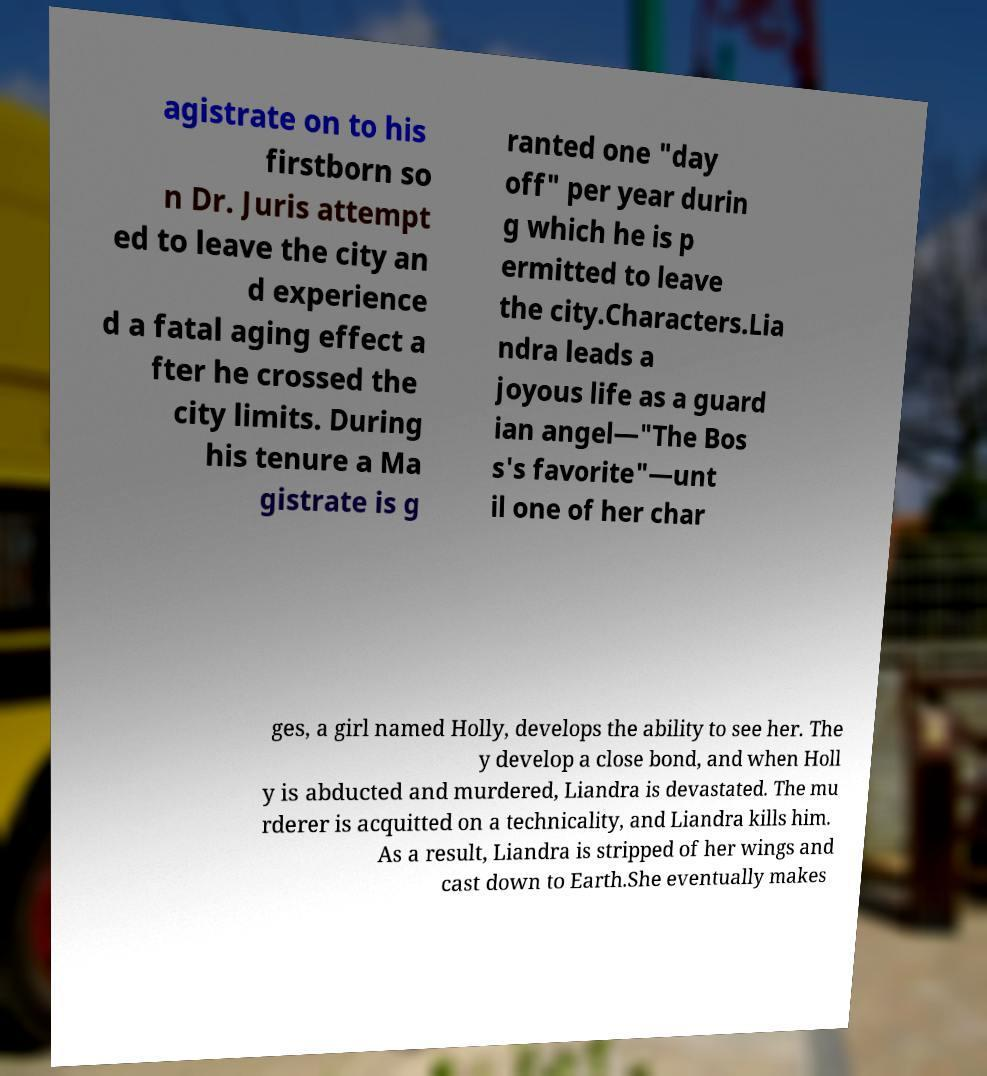Please read and relay the text visible in this image. What does it say? agistrate on to his firstborn so n Dr. Juris attempt ed to leave the city an d experience d a fatal aging effect a fter he crossed the city limits. During his tenure a Ma gistrate is g ranted one "day off" per year durin g which he is p ermitted to leave the city.Characters.Lia ndra leads a joyous life as a guard ian angel—"The Bos s's favorite"—unt il one of her char ges, a girl named Holly, develops the ability to see her. The y develop a close bond, and when Holl y is abducted and murdered, Liandra is devastated. The mu rderer is acquitted on a technicality, and Liandra kills him. As a result, Liandra is stripped of her wings and cast down to Earth.She eventually makes 